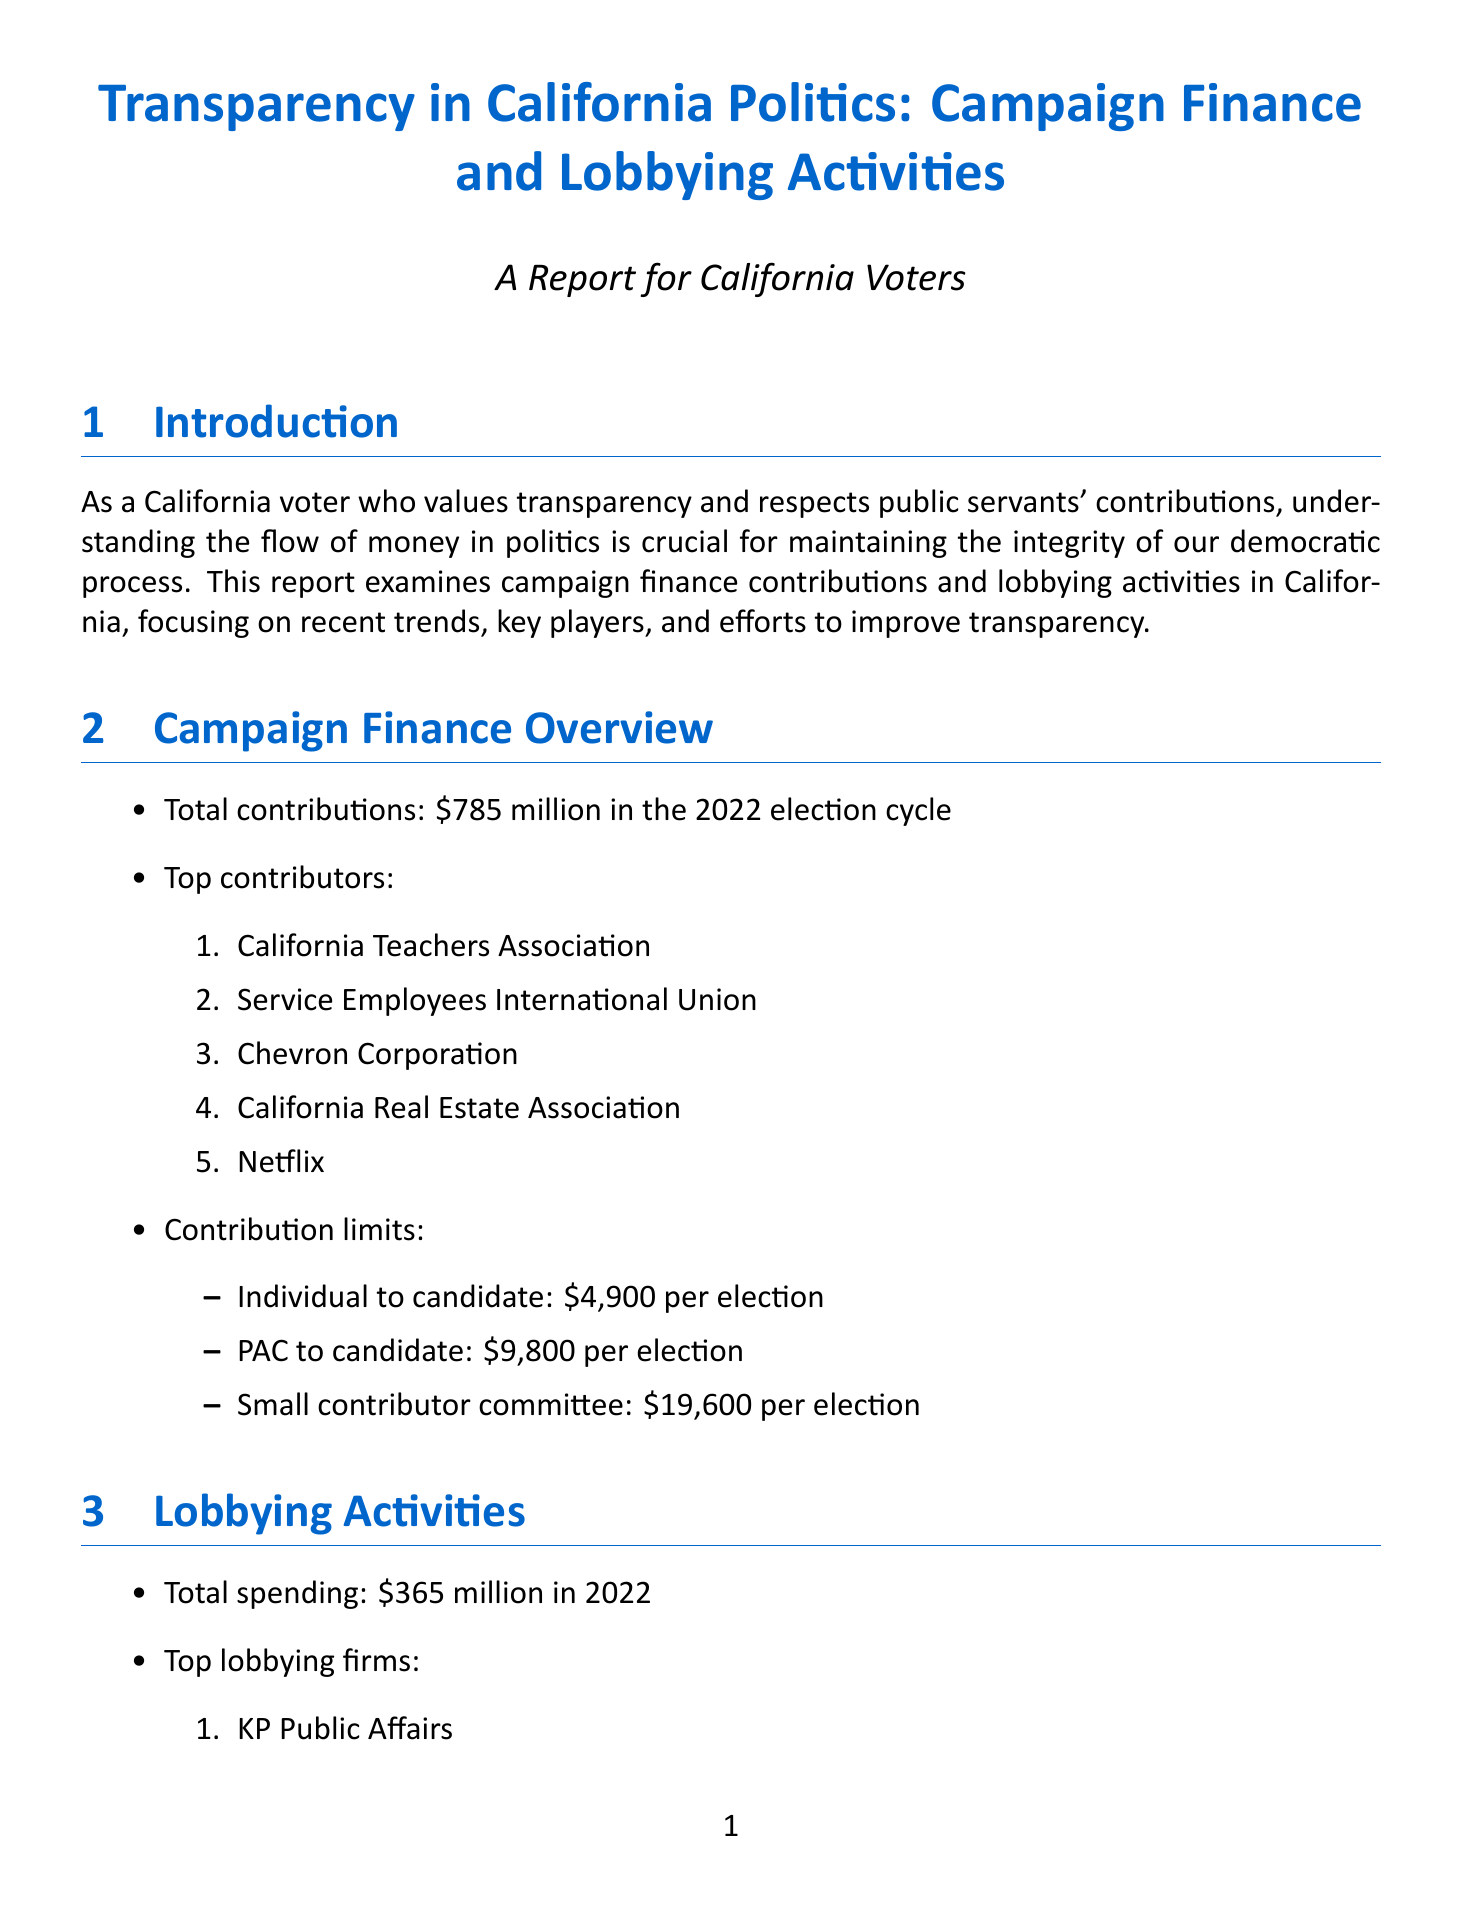what is the total amount of campaign finance contributions in the 2022 election cycle? The total amount of campaign finance contributions in the 2022 election cycle is specified in the report as $785 million.
Answer: $785 million who are the top contributors listed in the report? The top contributors are identified in a list within the campaign finance overview section, which includes various organizations.
Answer: California Teachers Association, Service Employees International Union, Chevron Corporation, California Real Estate Association, Netflix what is the contribution limit for an individual to a candidate per election? The contribution limit is summarized in the report's campaign finance overview, specifically for individuals contributing to candidates.
Answer: $4,900 per election which issues were most lobbied according to the report? The report provides a list of issues that received the most lobbying attention, presented under the lobbying activities section.
Answer: Healthcare, Energy and Environment, Taxation, Education, Housing what are the recent legislations aimed at improving transparency? The recent legislations that enhance transparency are highlighted in the transparency measures section of the report.
Answer: AB 1089, SB 1483 how much was spent on lobbying activities in 2022? The report specifies the total spending on lobbying activities for the year 2022.
Answer: $365 million what tools are available for public access to campaign finance data? The report details various tools available to the public for accessing campaign finance information, categorized under public access tools.
Answer: California Secretary of State's Campaign Finance and Lobbying Activities Portal, Follow the Money, MapLight what are some challenges identified for improving transparency? The report lists several challenges that need to be addressed to improve transparency in campaign finance and lobbying.
Answer: Closing loopholes in independent expenditure reporting, Enhancing real-time disclosure of contributions, Improving user-friendliness of public databases, Addressing dark money in politics, Strengthening enforcement of existing regulations 